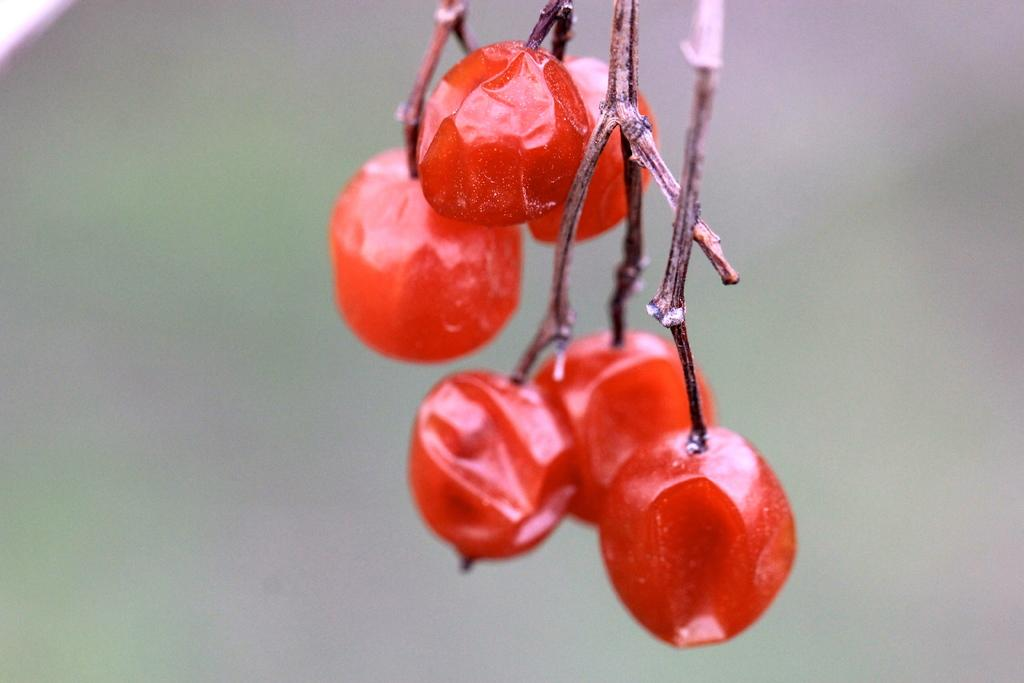What type of food can be seen in the image? There are fruits in the image. Can you describe the background of the image? The background of the image is blurred. What angle do the fruits appear to be at in the image? The angle at which the fruits appear in the image cannot be determined from the image itself. What is the temper of the substance in the image? There is no substance mentioned in the image, and therefore no temper can be determined. 